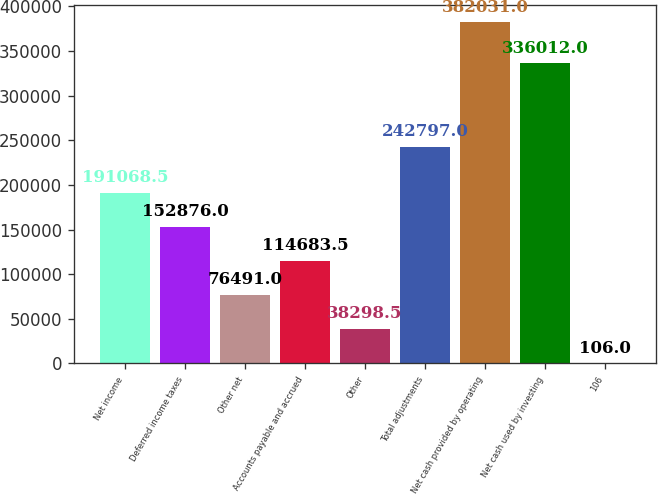Convert chart to OTSL. <chart><loc_0><loc_0><loc_500><loc_500><bar_chart><fcel>Net income<fcel>Deferred income taxes<fcel>Other net<fcel>Accounts payable and accrued<fcel>Other<fcel>Total adjustments<fcel>Net cash provided by operating<fcel>Net cash used by investing<fcel>106<nl><fcel>191068<fcel>152876<fcel>76491<fcel>114684<fcel>38298.5<fcel>242797<fcel>382031<fcel>336012<fcel>106<nl></chart> 